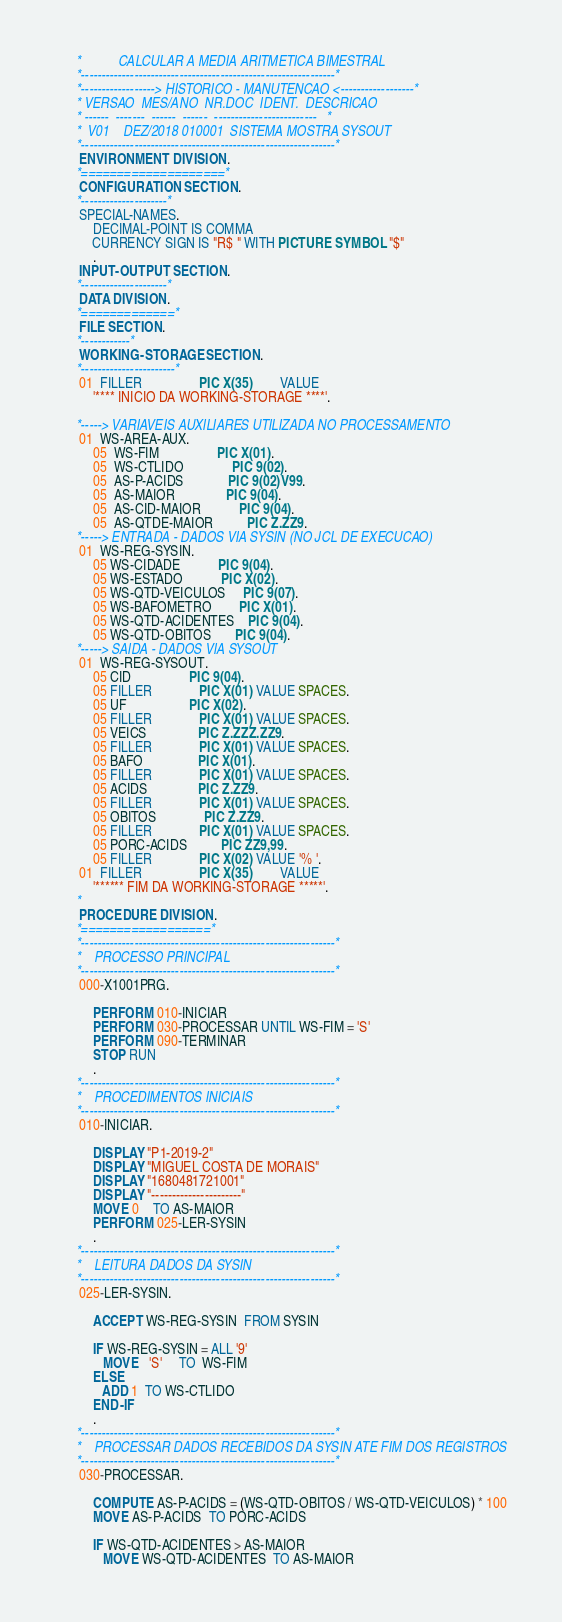Convert code to text. <code><loc_0><loc_0><loc_500><loc_500><_COBOL_>      *           CALCULAR A MEDIA ARITMETICA BIMESTRAL
      *--------------------------------------------------------------*
      *------------------> HISTORICO - MANUTENCAO <------------------*
      * VERSAO  MES/ANO  NR.DOC  IDENT.  DESCRICAO
      * ------  -------  ------  ------  -------------------------   *
      *  V01    DEZ/2018 010001  SISTEMA MOSTRA SYSOUT
      *--------------------------------------------------------------*
       ENVIRONMENT DIVISION.
      *====================*
       CONFIGURATION SECTION.
      *---------------------*
       SPECIAL-NAMES.
           DECIMAL-POINT IS COMMA
           CURRENCY SIGN IS "R$ " WITH PICTURE SYMBOL "$"
           .
       INPUT-OUTPUT SECTION.
      *---------------------*
       DATA DIVISION.
      *=============*
       FILE SECTION.
      *------------*
       WORKING-STORAGE SECTION.
      *-----------------------*
       01  FILLER                 PIC X(35)        VALUE
           '**** INICIO DA WORKING-STORAGE ****'.

      *-----> VARIAVEIS AUXILIARES UTILIZADA NO PROCESSAMENTO
       01  WS-AREA-AUX.
           05  WS-FIM                 PIC X(01).
           05  WS-CTLIDO              PIC 9(02).
           05  AS-P-ACIDS             PIC 9(02)V99.
           05  AS-MAIOR               PIC 9(04).
           05  AS-CID-MAIOR           PIC 9(04).
           05  AS-QTDE-MAIOR          PIC Z.ZZ9.
      *-----> ENTRADA - DADOS VIA SYSIN (NO JCL DE EXECUCAO)
       01  WS-REG-SYSIN.
           05 WS-CIDADE           PIC 9(04).
           05 WS-ESTADO           PIC X(02).
           05 WS-QTD-VEICULOS     PIC 9(07).
           05 WS-BAFOMETRO        PIC X(01).
           05 WS-QTD-ACIDENTES    PIC 9(04).
           05 WS-QTD-OBITOS       PIC 9(04).
      *-----> SAIDA - DADOS VIA SYSOUT
       01  WS-REG-SYSOUT.
           05 CID                 PIC 9(04).
           05 FILLER              PIC X(01) VALUE SPACES.
           05 UF                  PIC X(02).
           05 FILLER              PIC X(01) VALUE SPACES.
           05 VEICS               PIC Z.ZZZ.ZZ9.
           05 FILLER              PIC X(01) VALUE SPACES.
           05 BAFO                PIC X(01).
           05 FILLER              PIC X(01) VALUE SPACES.
           05 ACIDS               PIC Z.ZZ9.
           05 FILLER              PIC X(01) VALUE SPACES.
           05 OBITOS              PIC Z.ZZ9.
           05 FILLER              PIC X(01) VALUE SPACES.
           05 PORC-ACIDS          PIC ZZ9,99.
           05 FILLER              PIC X(02) VALUE '% '.
       01  FILLER                 PIC X(35)        VALUE
           '****** FIM DA WORKING-STORAGE *****'.
      *
       PROCEDURE DIVISION.
      *==================*
      *--------------------------------------------------------------*
      *    PROCESSO PRINCIPAL
      *--------------------------------------------------------------*
       000-X1001PRG.

           PERFORM 010-INICIAR
           PERFORM 030-PROCESSAR UNTIL WS-FIM = 'S'
           PERFORM 090-TERMINAR
           STOP RUN
           .
      *--------------------------------------------------------------*
      *    PROCEDIMENTOS INICIAIS
      *--------------------------------------------------------------*
       010-INICIAR.

           DISPLAY "P1-2019-2"
           DISPLAY "MIGUEL COSTA DE MORAIS"
           DISPLAY "1680481721001"
           DISPLAY "----------------------"
           MOVE 0    TO AS-MAIOR
           PERFORM 025-LER-SYSIN
           .
      *--------------------------------------------------------------*
      *    LEITURA DADOS DA SYSIN
      *--------------------------------------------------------------*
       025-LER-SYSIN.

           ACCEPT WS-REG-SYSIN  FROM SYSIN

           IF WS-REG-SYSIN = ALL '9'
              MOVE   'S'     TO  WS-FIM
           ELSE
              ADD 1  TO WS-CTLIDO
           END-IF
           .
      *--------------------------------------------------------------*
      *    PROCESSAR DADOS RECEBIDOS DA SYSIN ATE FIM DOS REGISTROS
      *--------------------------------------------------------------*
       030-PROCESSAR.

           COMPUTE AS-P-ACIDS = (WS-QTD-OBITOS / WS-QTD-VEICULOS) * 100
           MOVE AS-P-ACIDS  TO PORC-ACIDS

           IF WS-QTD-ACIDENTES > AS-MAIOR
              MOVE WS-QTD-ACIDENTES  TO AS-MAIOR</code> 